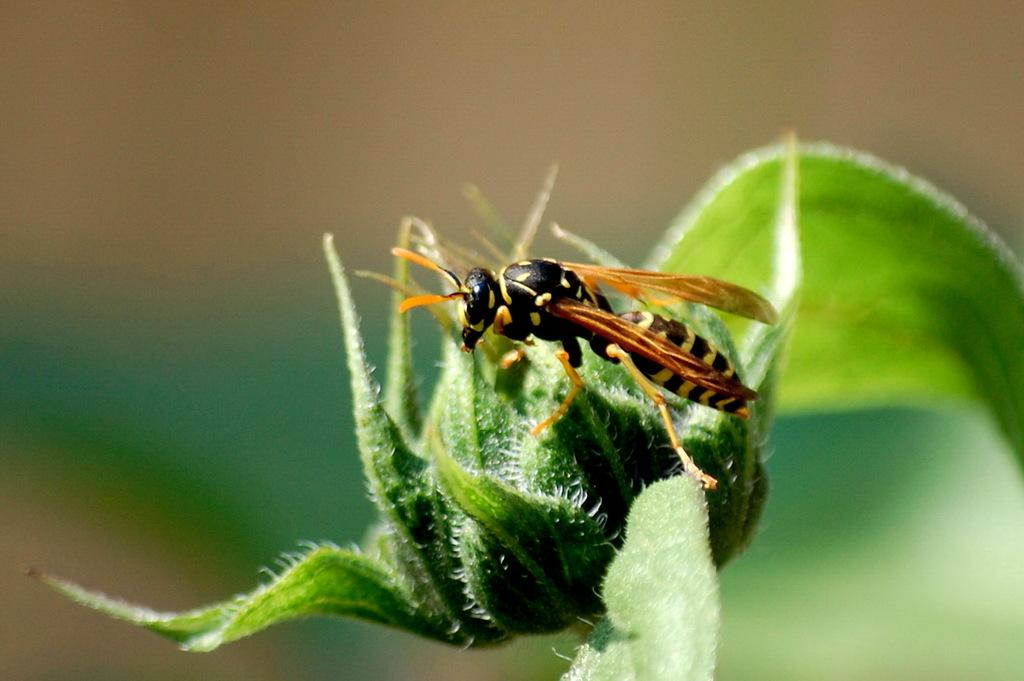What type of plant is visible in the image? There is a plant with a flower bud in the image. What kind of insect is present in the image? There is an insect with wings and legs in the image. Where is the insect located in relation to the plant? The insect is on the plant. What part of the plant can be seen in the image? There is a leaf visible in the image. Can you describe the unclear elements in the image? Unfortunately, the unclear elements cannot be described in detail as they are not distinct enough to identify. What type of cloud can be seen in the image? There is no cloud visible in the image; it features a plant and an insect. What is the relation between the self and the plant in the image? There is no reference to a self or any person in the image, so it is not possible to determine a relation between the self and the plant. 